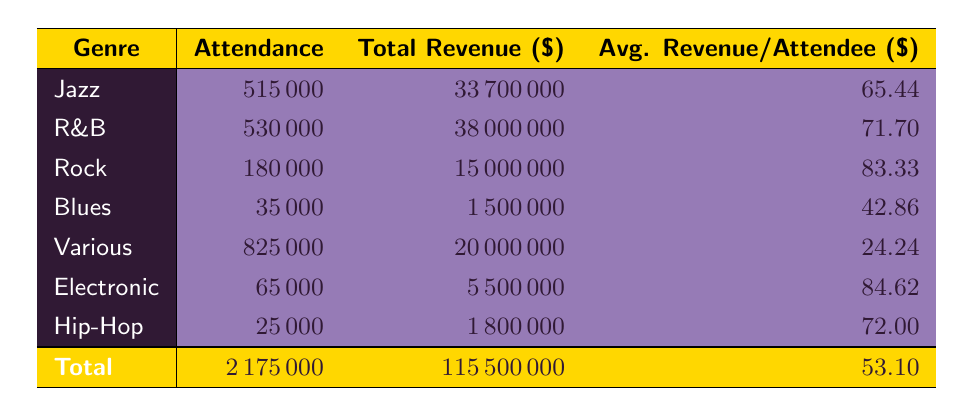What is the total attendance across all genres? To find the total attendance, we need to sum the attendance figures from each genre: 475000 (Jazz) + 530000 (R&B) + 180000 (Rock) + 35000 (Blues) + 825000 (Various) + 65000 (Electronic) + 25000 (Hip-Hop) = 2175000.
Answer: 2175000 Which genre has the highest average revenue per attendee? The average revenue per attendee for each genre is calculated as follows: Jazz: 33700000 / 515000 = 65.44, R&B: 38000000 / 530000 = 71.70, Rock: 15000000 / 180000 = 83.33, Blues: 1500000 / 35000 = 42.86, Various: 20000000 / 825000 = 24.24, Electronic: 5500000 / 65000 = 84.62, Hip-Hop: 1800000 / 25000 = 72.80. Comparing these values reveals that Electronic has the highest at 84.62.
Answer: Electronic Is the total revenue from Jazz festivals greater than the total revenue from Blues festivals? The total revenue from Jazz is 33700000, while the total revenue from Blues is 1500000. Since 33700000 is significantly greater than 1500000, the answer is yes.
Answer: Yes What is the combined revenue from R&B and Hip-Hop festivals? To find the combined revenue, we add the revenues from both genres: R&B revenue is 38000000 and Hip-Hop revenue is 1800000, so 38000000 + 1800000 = 39800000.
Answer: 39800000 Did the Various genre generate the least average revenue per attendee? The average revenue per attendee for the Various genre is calculated as 20000000 / 825000 = 24.24. Comparing this to other genres shows it's the lowest figure among them: Jazz (65.44), R&B (71.70), Rock (83.33), Blues (42.86), Electronic (84.62), and Hip-Hop (72.00). Therefore, it did generate the least average revenue per attendee.
Answer: Yes 